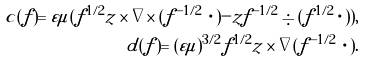Convert formula to latex. <formula><loc_0><loc_0><loc_500><loc_500>c ( f ) = \varepsilon \mu ( f ^ { 1 / 2 } z \times \nabla \times ( f ^ { - 1 / 2 } \, \cdot ) - z f ^ { - 1 / 2 } \div ( f ^ { 1 / 2 } \cdot ) ) , \\ d ( f ) = ( \varepsilon \mu ) ^ { 3 / 2 } f ^ { 1 / 2 } z \times \nabla ( f ^ { - 1 / 2 } \, \cdot ) .</formula> 